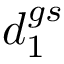<formula> <loc_0><loc_0><loc_500><loc_500>d _ { 1 } ^ { g s }</formula> 